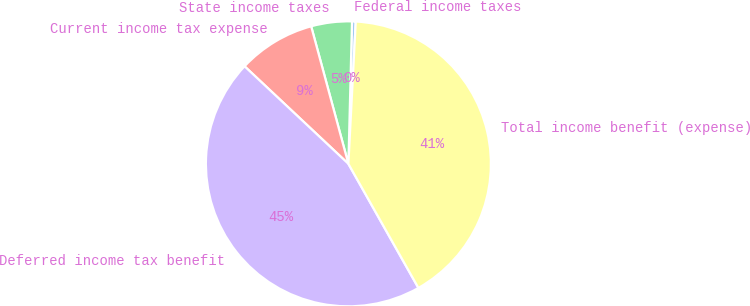Convert chart to OTSL. <chart><loc_0><loc_0><loc_500><loc_500><pie_chart><fcel>Federal income taxes<fcel>State income taxes<fcel>Current income tax expense<fcel>Deferred income tax benefit<fcel>Total income benefit (expense)<nl><fcel>0.42%<fcel>4.61%<fcel>8.79%<fcel>45.18%<fcel>41.0%<nl></chart> 